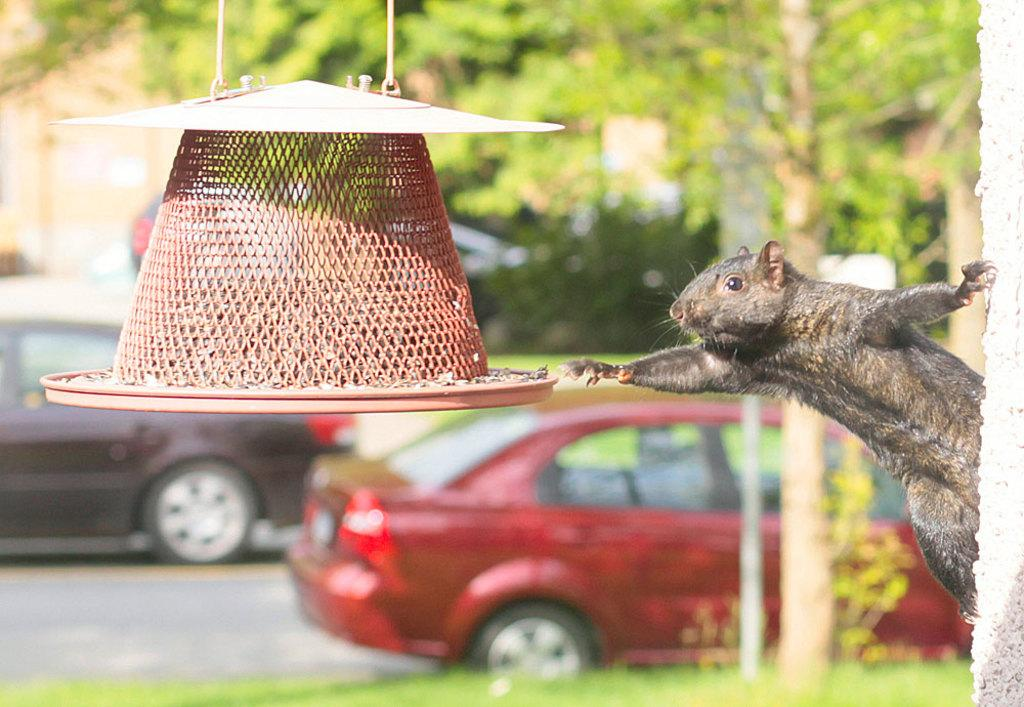What animal can be seen on the wall in the image? There is a squirrel on the wall in the image. What else is present in the image besides the squirrel? There is an object in the image. What can be seen in the background of the image? There are vehicles on the road and trees visible in the background of the image. What type of noise is the squirrel making in the image? The image does not provide any information about the squirrel making noise. 